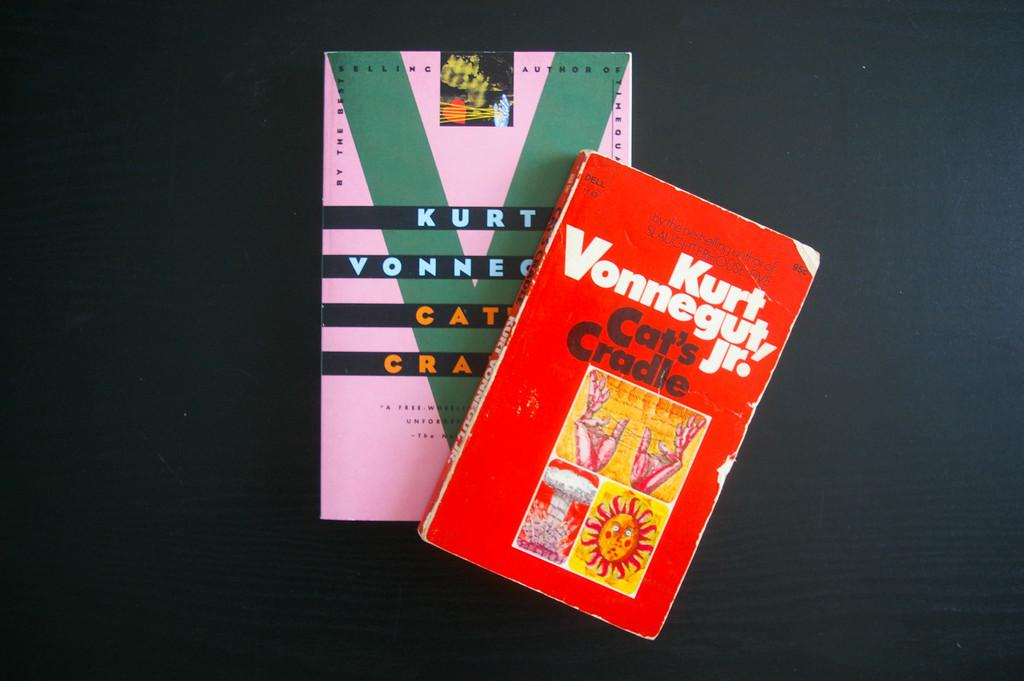<image>
Describe the image concisely. Two books on a table are different versions of Cat's Cradle. 